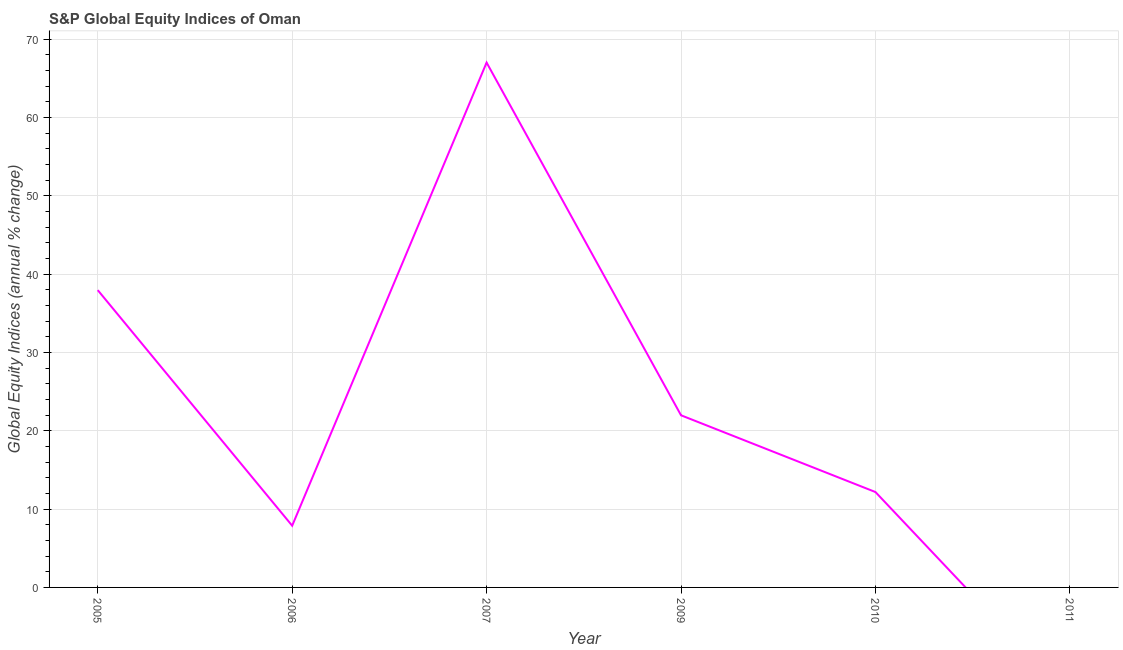What is the s&p global equity indices in 2010?
Give a very brief answer. 12.18. Across all years, what is the maximum s&p global equity indices?
Offer a terse response. 67.01. What is the sum of the s&p global equity indices?
Provide a succinct answer. 147. What is the difference between the s&p global equity indices in 2007 and 2010?
Your answer should be compact. 54.83. What is the average s&p global equity indices per year?
Give a very brief answer. 24.5. What is the median s&p global equity indices?
Ensure brevity in your answer.  17.08. What is the ratio of the s&p global equity indices in 2005 to that in 2010?
Keep it short and to the point. 3.12. Is the s&p global equity indices in 2007 less than that in 2010?
Provide a short and direct response. No. Is the difference between the s&p global equity indices in 2005 and 2007 greater than the difference between any two years?
Provide a succinct answer. No. What is the difference between the highest and the second highest s&p global equity indices?
Make the answer very short. 29.05. What is the difference between the highest and the lowest s&p global equity indices?
Your answer should be compact. 67.01. Does the s&p global equity indices monotonically increase over the years?
Offer a terse response. No. How many lines are there?
Offer a terse response. 1. How many years are there in the graph?
Your response must be concise. 6. Does the graph contain any zero values?
Your answer should be very brief. Yes. Does the graph contain grids?
Your answer should be compact. Yes. What is the title of the graph?
Your answer should be compact. S&P Global Equity Indices of Oman. What is the label or title of the Y-axis?
Your answer should be very brief. Global Equity Indices (annual % change). What is the Global Equity Indices (annual % change) in 2005?
Offer a very short reply. 37.96. What is the Global Equity Indices (annual % change) of 2006?
Your answer should be compact. 7.88. What is the Global Equity Indices (annual % change) of 2007?
Your answer should be very brief. 67.01. What is the Global Equity Indices (annual % change) of 2009?
Provide a short and direct response. 21.98. What is the Global Equity Indices (annual % change) of 2010?
Ensure brevity in your answer.  12.18. What is the Global Equity Indices (annual % change) in 2011?
Provide a succinct answer. 0. What is the difference between the Global Equity Indices (annual % change) in 2005 and 2006?
Make the answer very short. 30.08. What is the difference between the Global Equity Indices (annual % change) in 2005 and 2007?
Offer a very short reply. -29.05. What is the difference between the Global Equity Indices (annual % change) in 2005 and 2009?
Make the answer very short. 15.98. What is the difference between the Global Equity Indices (annual % change) in 2005 and 2010?
Ensure brevity in your answer.  25.78. What is the difference between the Global Equity Indices (annual % change) in 2006 and 2007?
Make the answer very short. -59.13. What is the difference between the Global Equity Indices (annual % change) in 2006 and 2009?
Keep it short and to the point. -14.1. What is the difference between the Global Equity Indices (annual % change) in 2006 and 2010?
Your response must be concise. -4.3. What is the difference between the Global Equity Indices (annual % change) in 2007 and 2009?
Your answer should be very brief. 45.03. What is the difference between the Global Equity Indices (annual % change) in 2007 and 2010?
Your response must be concise. 54.83. What is the difference between the Global Equity Indices (annual % change) in 2009 and 2010?
Provide a short and direct response. 9.8. What is the ratio of the Global Equity Indices (annual % change) in 2005 to that in 2006?
Make the answer very short. 4.82. What is the ratio of the Global Equity Indices (annual % change) in 2005 to that in 2007?
Your answer should be very brief. 0.57. What is the ratio of the Global Equity Indices (annual % change) in 2005 to that in 2009?
Your answer should be compact. 1.73. What is the ratio of the Global Equity Indices (annual % change) in 2005 to that in 2010?
Offer a very short reply. 3.12. What is the ratio of the Global Equity Indices (annual % change) in 2006 to that in 2007?
Keep it short and to the point. 0.12. What is the ratio of the Global Equity Indices (annual % change) in 2006 to that in 2009?
Give a very brief answer. 0.36. What is the ratio of the Global Equity Indices (annual % change) in 2006 to that in 2010?
Provide a succinct answer. 0.65. What is the ratio of the Global Equity Indices (annual % change) in 2007 to that in 2009?
Give a very brief answer. 3.05. What is the ratio of the Global Equity Indices (annual % change) in 2007 to that in 2010?
Offer a very short reply. 5.5. What is the ratio of the Global Equity Indices (annual % change) in 2009 to that in 2010?
Provide a short and direct response. 1.8. 